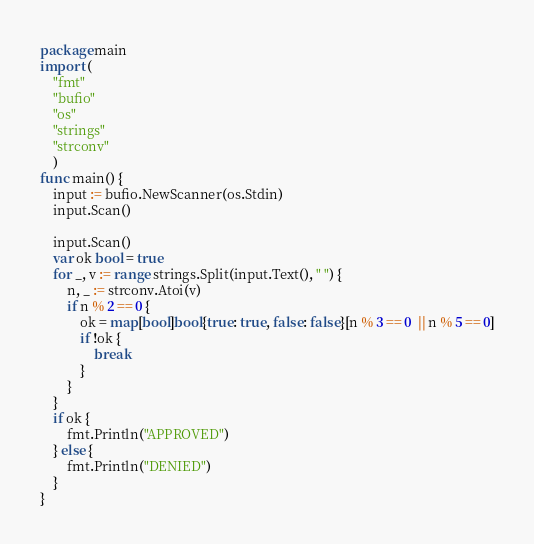Convert code to text. <code><loc_0><loc_0><loc_500><loc_500><_Go_>package main
import (
    "fmt"
    "bufio"
    "os"
    "strings"
    "strconv"
    )
func main() {
    input := bufio.NewScanner(os.Stdin)
    input.Scan()
    
    input.Scan()
    var ok bool = true
    for _, v := range strings.Split(input.Text(), " ") {
        n, _ := strconv.Atoi(v)
        if n % 2 == 0 {
            ok = map[bool]bool{true: true, false: false}[n % 3 == 0  || n % 5 == 0]
            if !ok {
                break
            }
        }
    }
    if ok {
        fmt.Println("APPROVED")
    } else {
        fmt.Println("DENIED")
    }
}</code> 